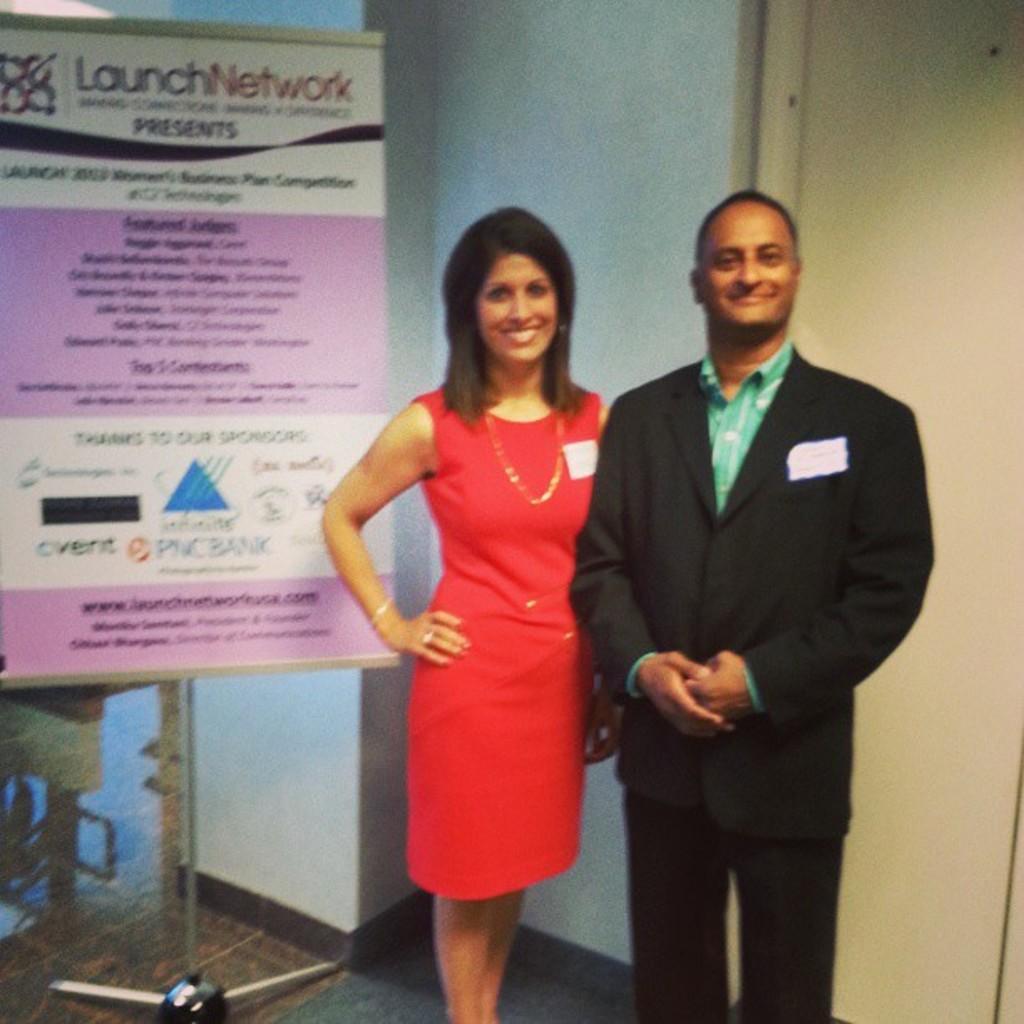In one or two sentences, can you explain what this image depicts? On the background of the picture we can see a wall and this is a door. Here we cans a man and a woman giving pose to the camera. She is in red dress. He is wearing a black colour blazer and trousers. At the left side of the picture we can see a board starting "launch network". This is a stand. This is a floor. 